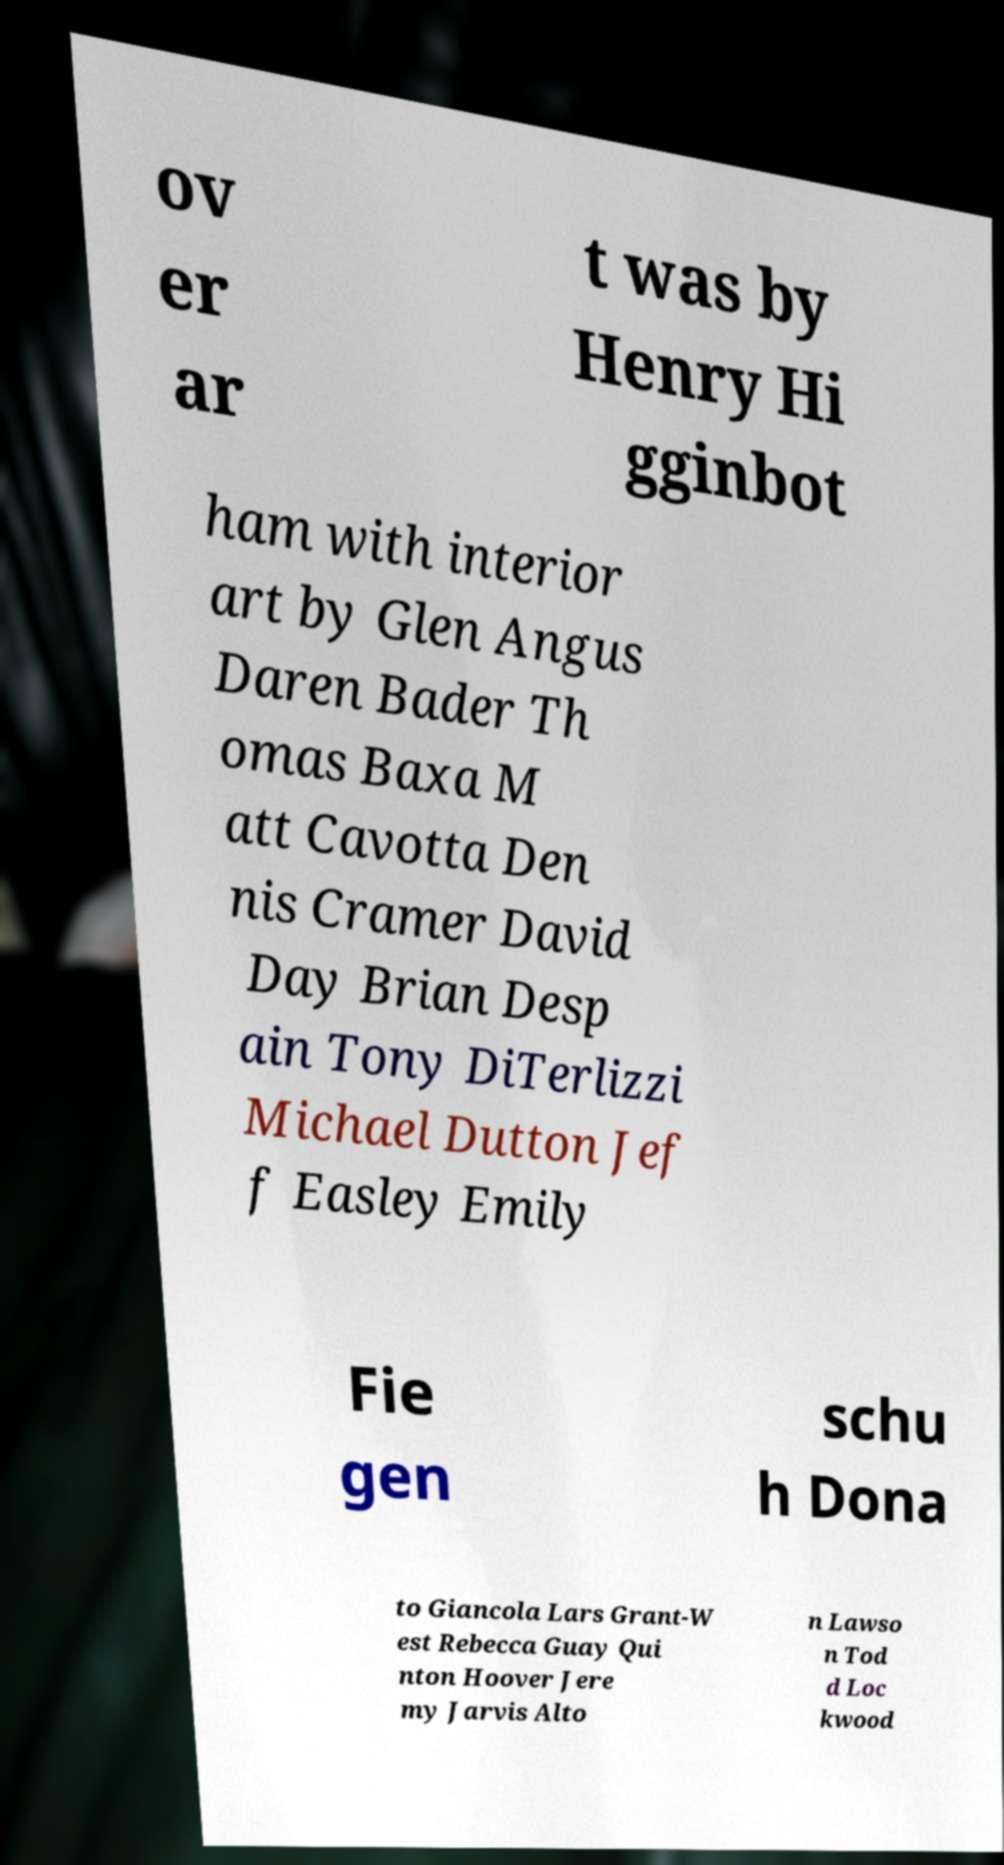Please read and relay the text visible in this image. What does it say? ov er ar t was by Henry Hi gginbot ham with interior art by Glen Angus Daren Bader Th omas Baxa M att Cavotta Den nis Cramer David Day Brian Desp ain Tony DiTerlizzi Michael Dutton Jef f Easley Emily Fie gen schu h Dona to Giancola Lars Grant-W est Rebecca Guay Qui nton Hoover Jere my Jarvis Alto n Lawso n Tod d Loc kwood 